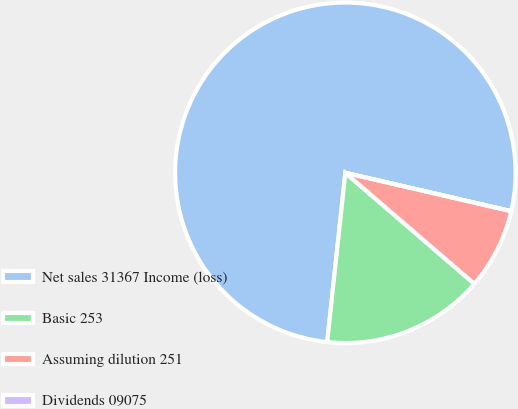Convert chart. <chart><loc_0><loc_0><loc_500><loc_500><pie_chart><fcel>Net sales 31367 Income (loss)<fcel>Basic 253<fcel>Assuming dilution 251<fcel>Dividends 09075<nl><fcel>76.92%<fcel>15.39%<fcel>7.69%<fcel>0.0%<nl></chart> 